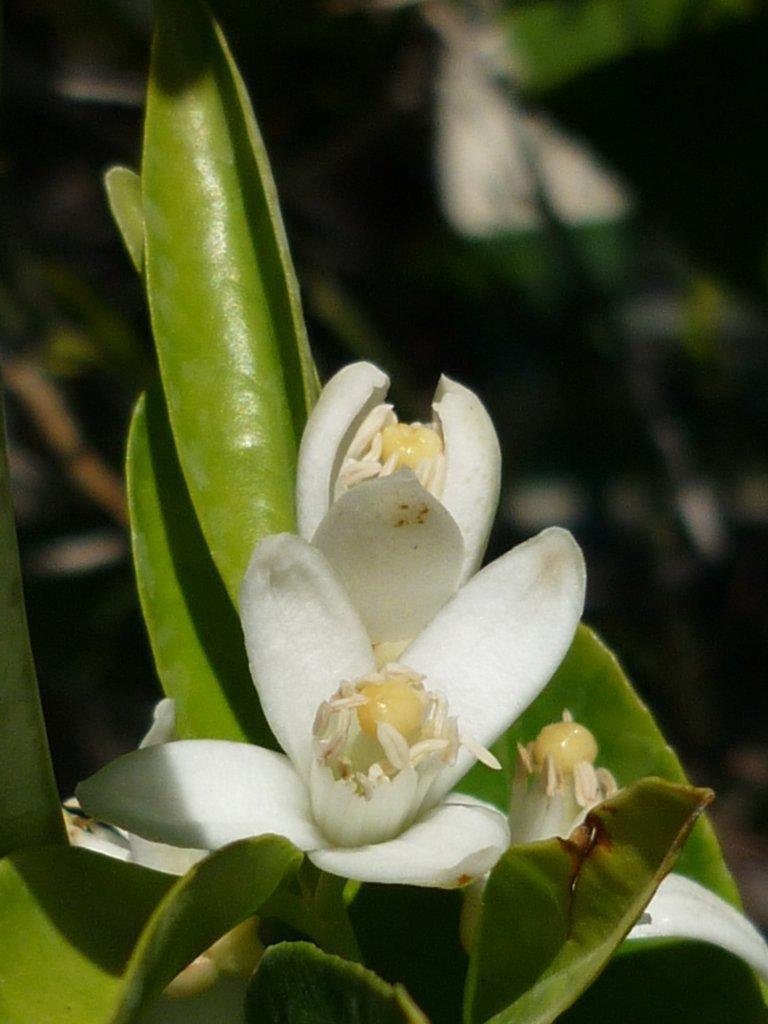Could you give a brief overview of what you see in this image? In this picture we can see flowers and leaves. In the background we can see some objects and it is blurry. 